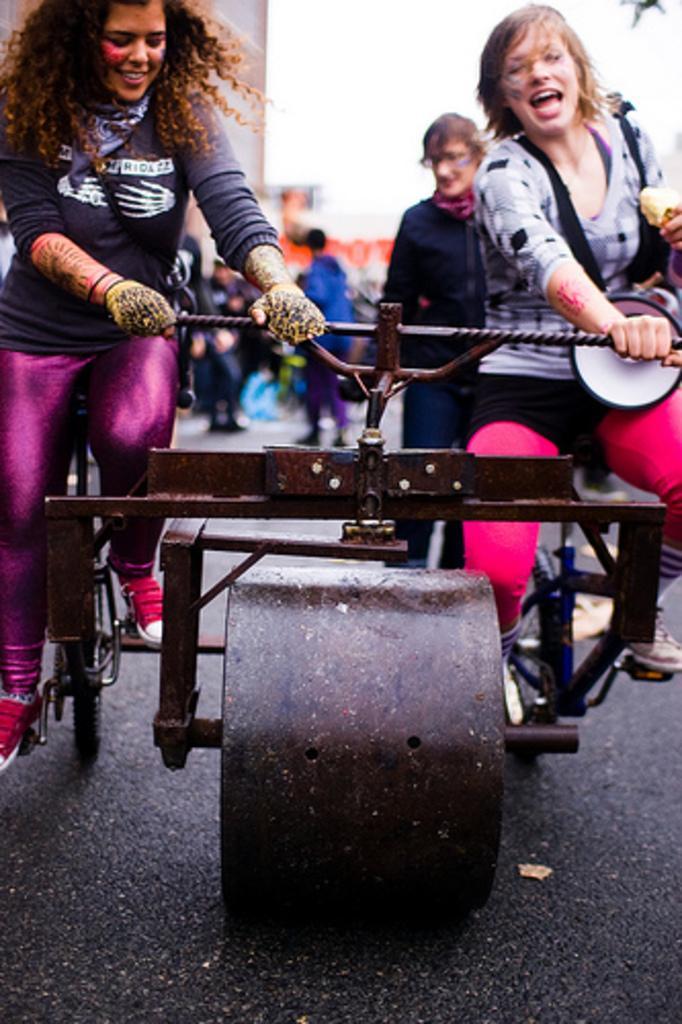How would you summarize this image in a sentence or two? In this picture we can see two women sitting on a vehicle and smiling and in the background we can see a group of people standing on the road, buildings and it is blurry. 